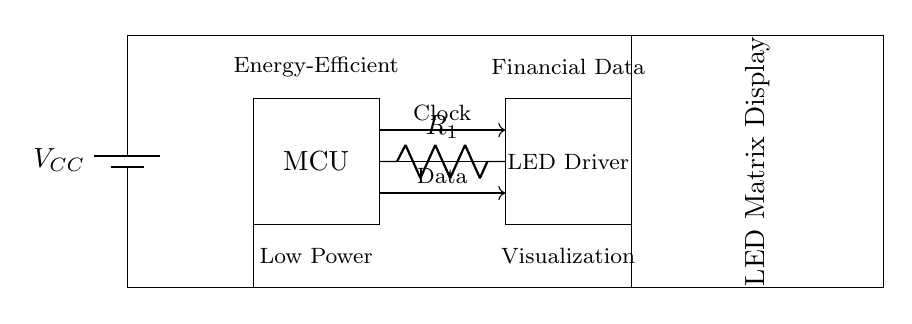What component is used to limit current to the LED matrix? The circuit includes a current limiting resistor labeled R1. This resistor is present in series with the LED driver and is essential for ensuring the LEDs operate within their specified current range.
Answer: R1 What is the function of the MCU in this circuit? The microcontroller (MCU) serves as the control unit that processes data and sends commands to the LED driver. It interfaces with the LED driver using data and clock signals to facilitate the display of real-time financial data.
Answer: Control unit How many data lines are shown in the circuit? The circuit diagram indicates two data lines: one for data transfer and another for the clock signal. These lines are essential for the communication between the microcontroller and the LED driver.
Answer: Two What is the main purpose of this circuit? The primary purpose of this energy-efficient LED display driver circuit is to visualize financial data in real-time by controlling an LED matrix display with an MCU. This allows users to see current financial information visually.
Answer: Visualization What type of voltage source is used in this circuit? The circuit uses a battery as its power supply, indicated by the battery symbol labeled as VCC. This configuration allows the circuit to operate on low power, making it suitable for applications like portable financial displays.
Answer: Battery 